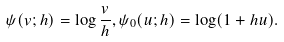Convert formula to latex. <formula><loc_0><loc_0><loc_500><loc_500>\psi ( v ; h ) = \log \frac { v } { h } , \psi _ { 0 } ( u ; h ) = \log ( 1 + h u ) .</formula> 